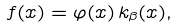Convert formula to latex. <formula><loc_0><loc_0><loc_500><loc_500>f ( x ) = \varphi ( x ) \, k _ { \beta } ( x ) ,</formula> 